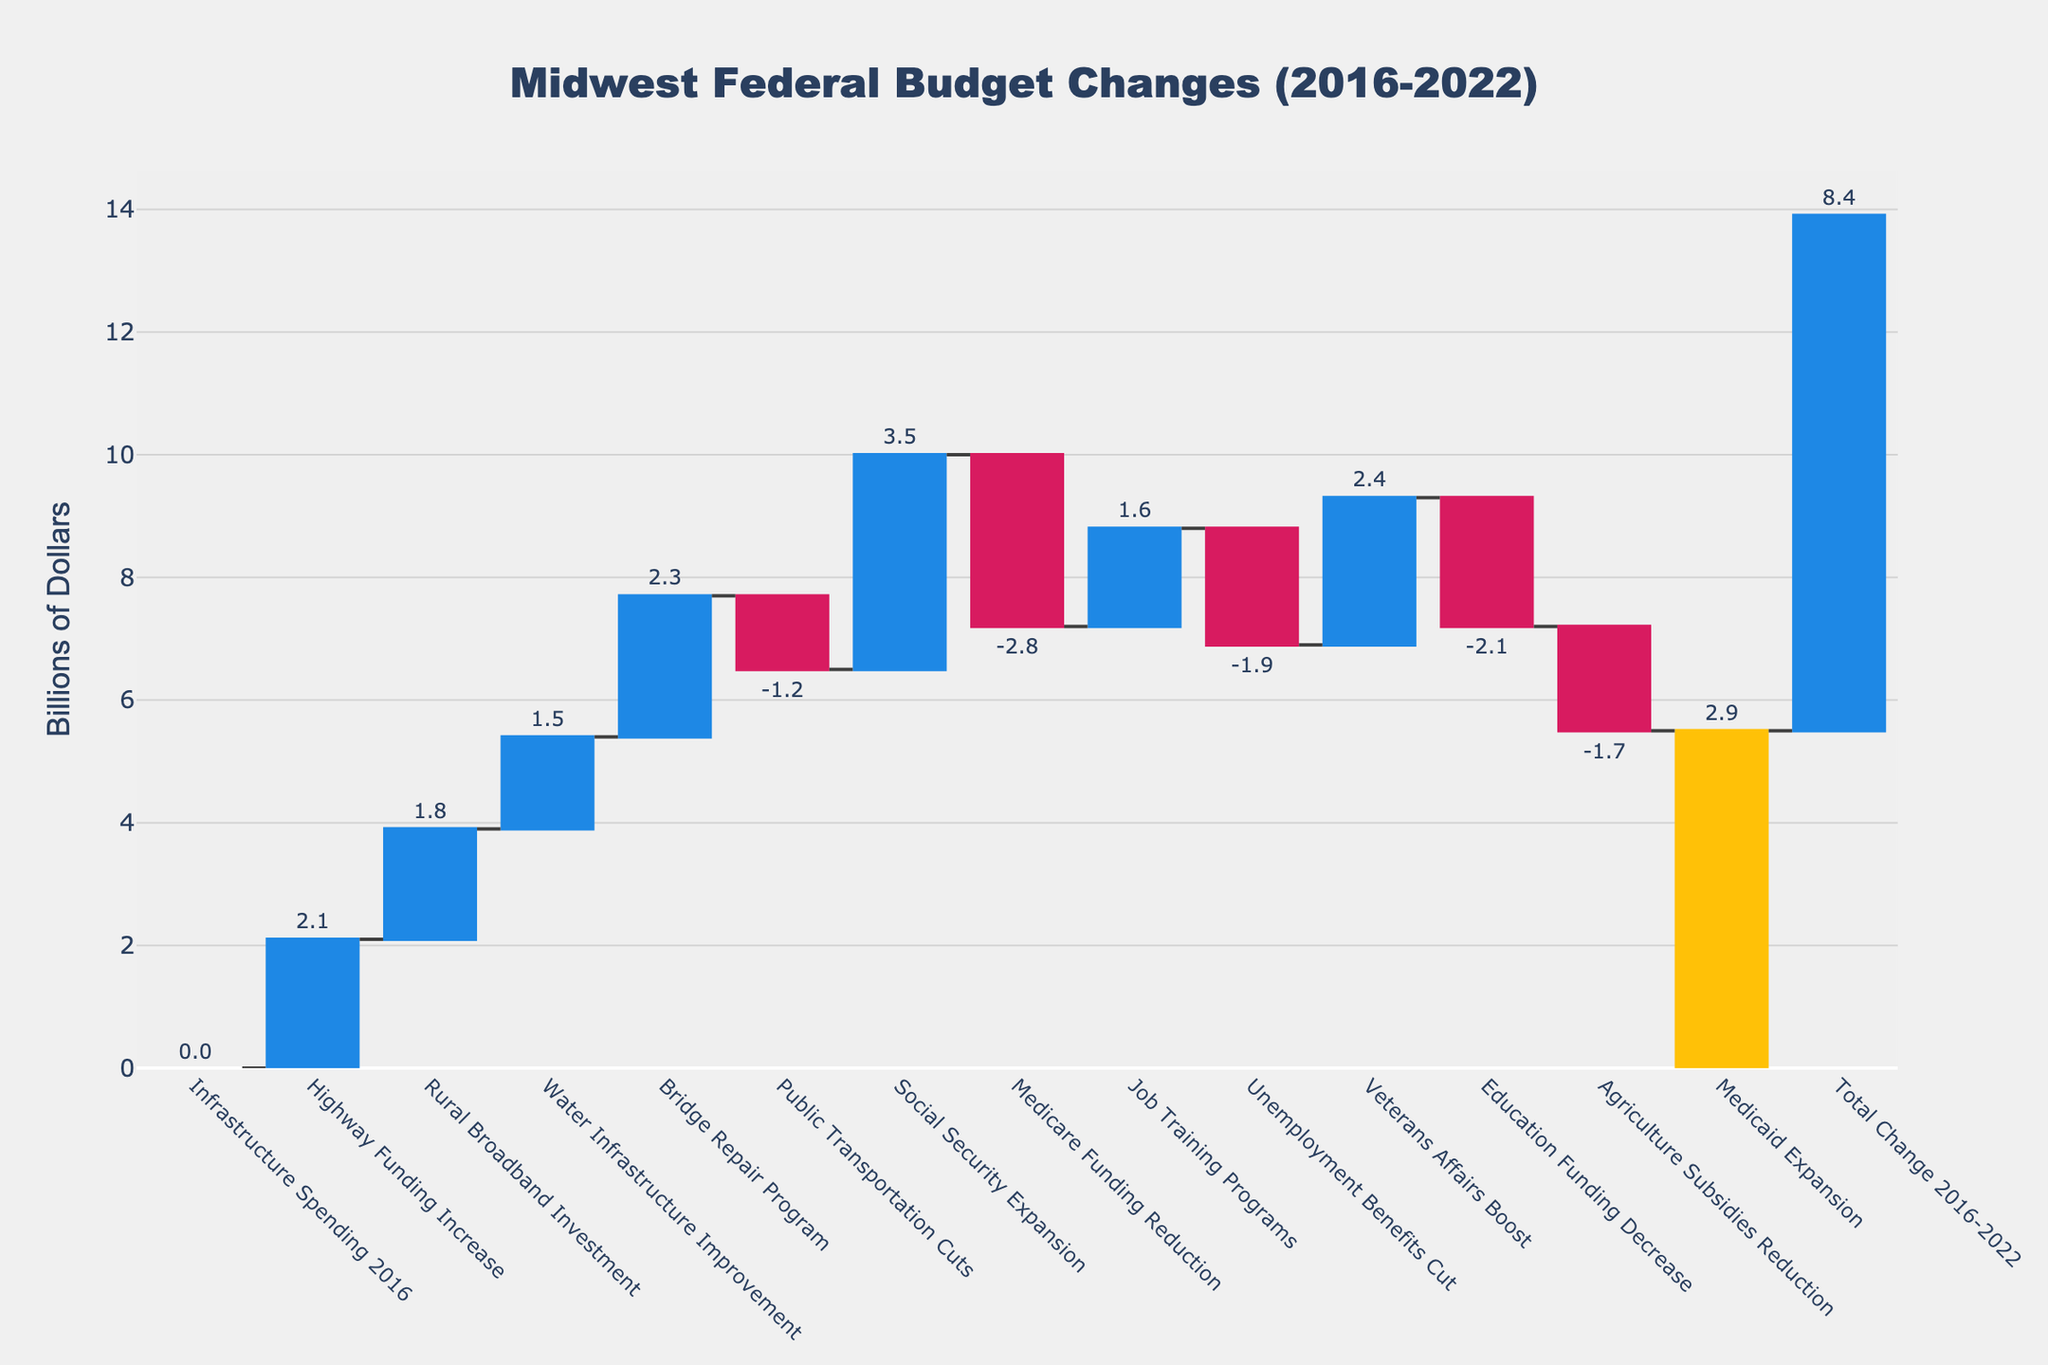what's the total increase in infrastructure spending? To find the total increase in infrastructure spending, sum the values for Highway Funding Increase, Rural Broadband Investment, Water Infrastructure Improvement, and Bridge Repair Program: 2.1 + 1.8 + 1.5 + 2.3 = 7.7
Answer: 7.7 what's the net change in spending for social programs, excluding Medicare? Sum the changes for Social Security Expansion, Job Training Programs, Unemployment Benefits Cut, Veterans Affairs Boost, Education Funding Decrease, Agriculture Subsidies Reduction, and Medicaid Expansion: 3.5 + 1.6 + (-1.9) + 2.4 + (-2.1) + (-1.7) + 2.9 = 4.7
Answer: 4.7 which category had the highest decrease in funding? Look at the negative values and find the largest magnitude. Medicare Funding Reduction has the highest decrease at -2.8
Answer: Medicare Funding Reduction how does the increase in Social Security Expansion compare to the cut in Medicare Funding? Compare the absolute values of Social Security Expansion (3.5) and Medicare Funding Reduction (-2.8). 3.5 is greater than 2.8, so Social Security Expansion increased more than Medicare Funding was cut.
Answer: Social Security Expansion increased more what is the combined effect of Education Funding Decrease and Agriculture Subsidies Reduction? Sum the values for Education Funding Decrease and Agriculture Subsidies Reduction: -2.1 + (-1.7) = -3.8 Billion
Answer: -3.8 how much total value did the healthcare-related categories contribute to the overall change? Sum the values for Medicare Funding Reduction and Medicaid Expansion: -2.8 + 2.9 = 0.1 Billion
Answer: 0.1 which category had the smallest positive change? Among the positive changes, Job Training Programs had the smallest change at 1.6
Answer: Job Training Programs how did the total budget change for 2016-2022 compare to the category with the largest increase? The total change for 2016-2022 is 8.4, and the category with the largest increase is Social Security Expansion at 3.5 Billion. 8.4 is greater than 3.5.
Answer: Total change is greater compare the changes in infrastructure spending with changes in social program spending? Infrastructure spending changes sum to 7.7 Billion, and social program spending changes (excluding Medicare) sum to 4.7 Billion. 7.7 is greater than 4.7.
Answer: Infrastructure spending increased more what's the overall impact of budget changes in Midwestern federal budget allocations? The overall impact is represented by the last category, 'Total Change 2016-2022', which is 8.4 Billion. This shows the net change after all increases and decreases.
Answer: 8.4 Billion 